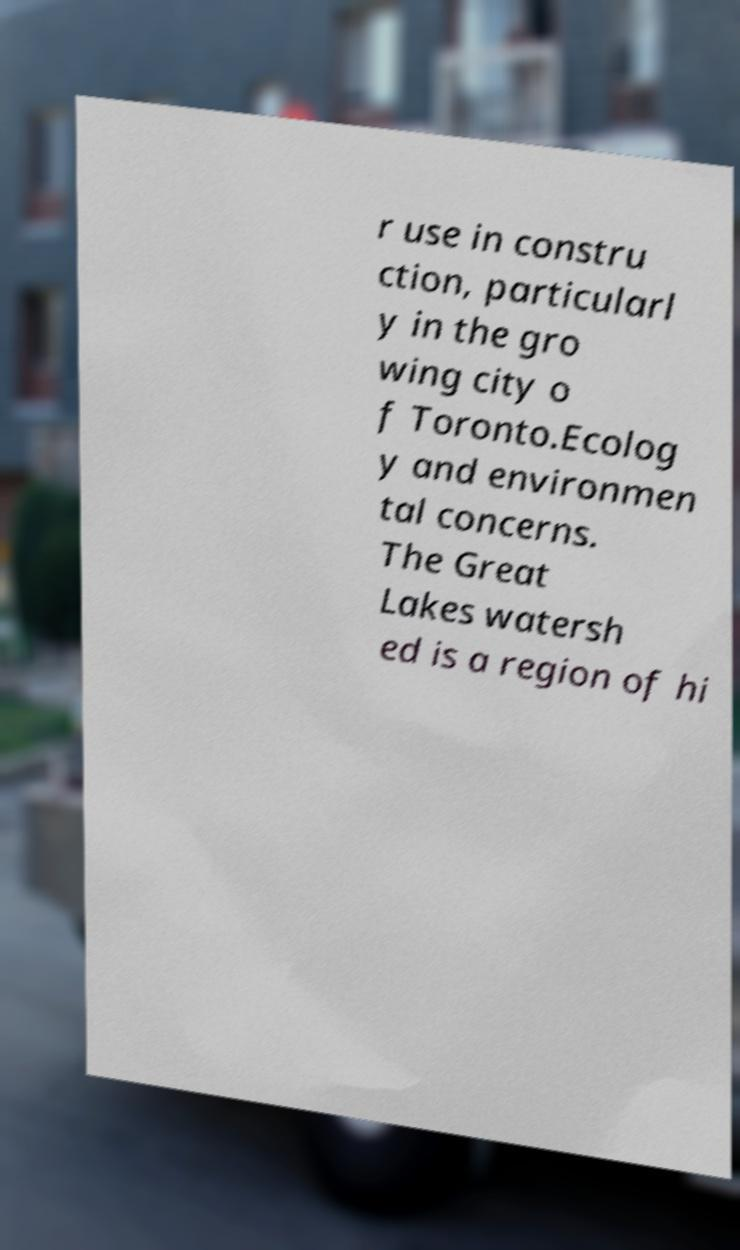Could you extract and type out the text from this image? r use in constru ction, particularl y in the gro wing city o f Toronto.Ecolog y and environmen tal concerns. The Great Lakes watersh ed is a region of hi 